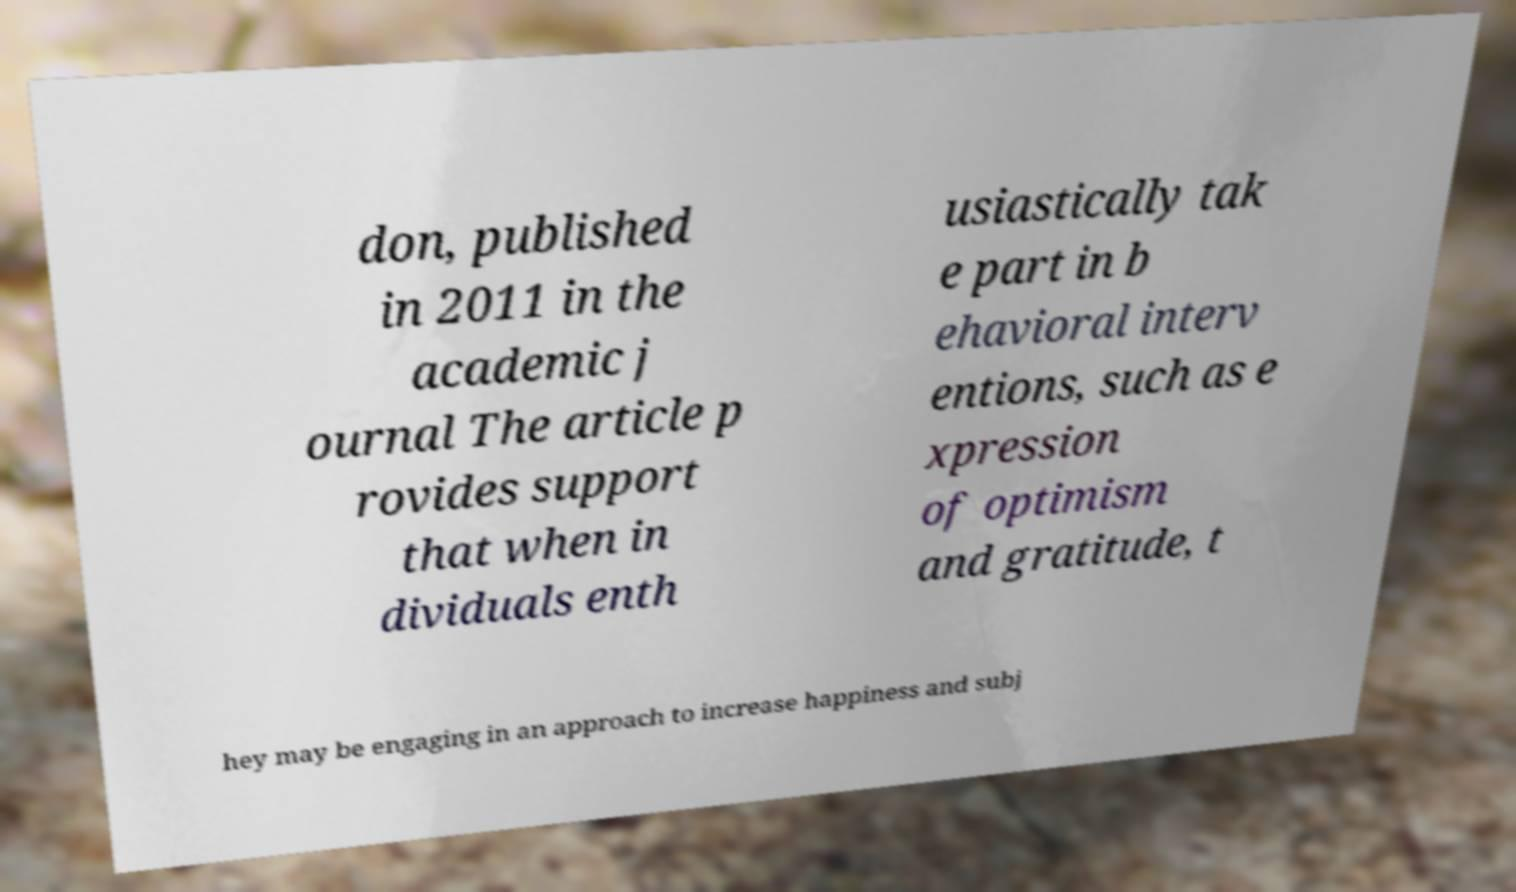Please read and relay the text visible in this image. What does it say? don, published in 2011 in the academic j ournal The article p rovides support that when in dividuals enth usiastically tak e part in b ehavioral interv entions, such as e xpression of optimism and gratitude, t hey may be engaging in an approach to increase happiness and subj 